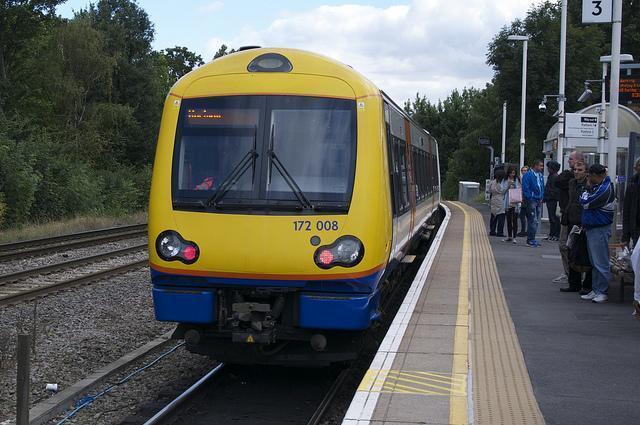How many people can you see?
Give a very brief answer. 2. How many giraffes are holding their neck horizontally?
Give a very brief answer. 0. 